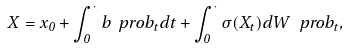<formula> <loc_0><loc_0><loc_500><loc_500>X = x _ { 0 } + \int _ { 0 } ^ { \cdot } b ^ { \ } p r o b _ { t } d t + \int _ { 0 } ^ { \cdot } \sigma ( X _ { t } ) d W ^ { \ } p r o b _ { t } ,</formula> 